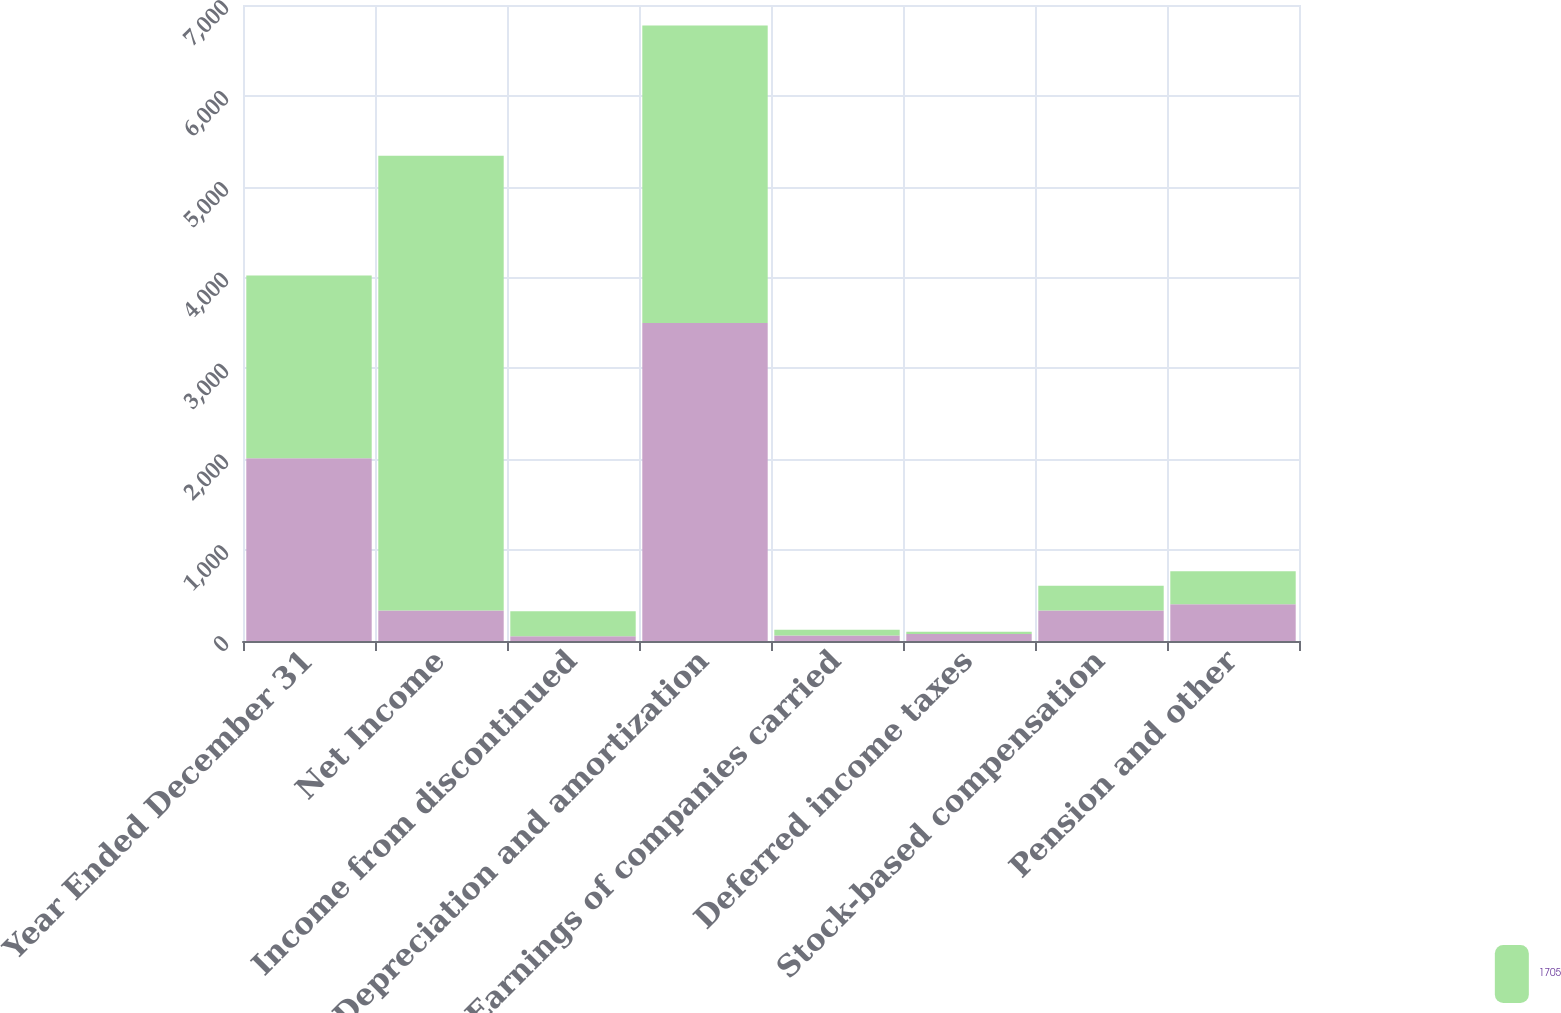Convert chart. <chart><loc_0><loc_0><loc_500><loc_500><stacked_bar_chart><ecel><fcel>Year Ended December 31<fcel>Net Income<fcel>Income from discontinued<fcel>Depreciation and amortization<fcel>Earnings of companies carried<fcel>Deferred income taxes<fcel>Stock-based compensation<fcel>Pension and other<nl><fcel>nan<fcel>2012<fcel>335<fcel>51<fcel>3500<fcel>61<fcel>76<fcel>335<fcel>404<nl><fcel>1705<fcel>2011<fcel>5007<fcel>277<fcel>3274<fcel>64<fcel>26<fcel>272<fcel>365<nl></chart> 